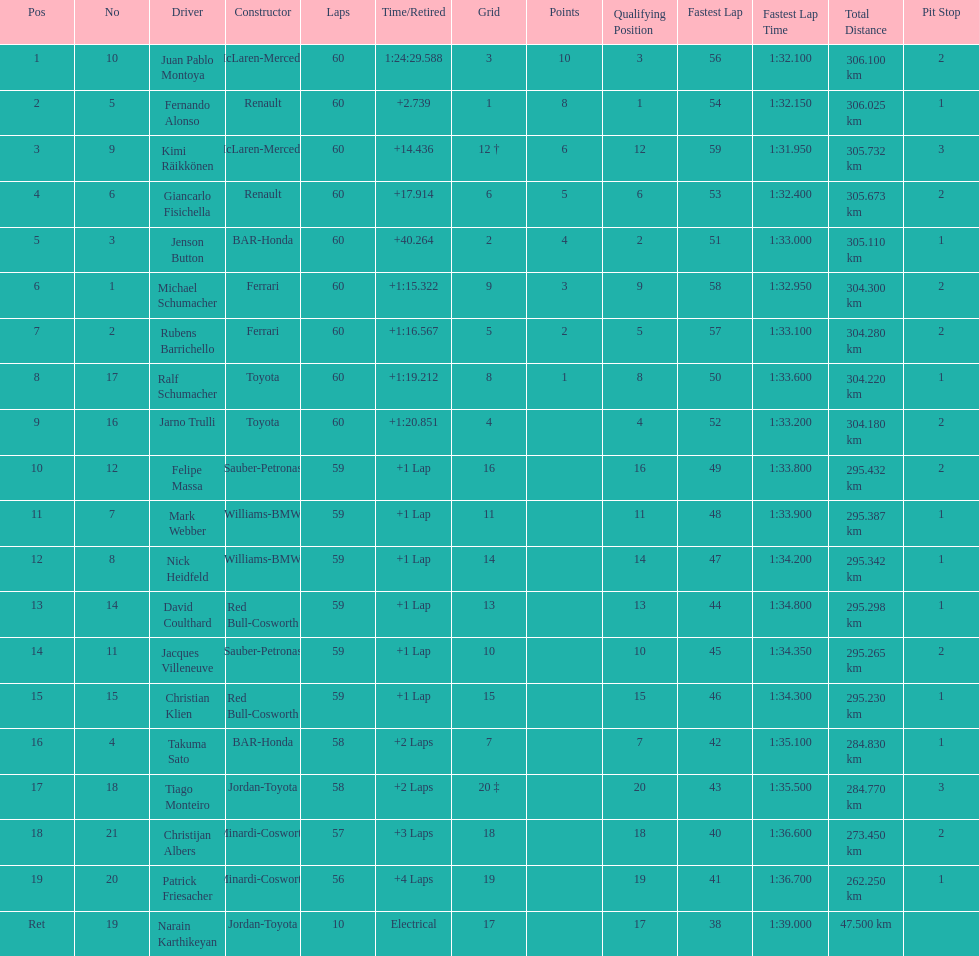How many drivers from germany? 3. 